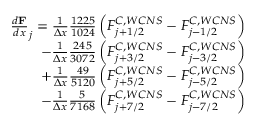<formula> <loc_0><loc_0><loc_500><loc_500>\begin{array} { r } { \frac { d \mathbf F } { d x } _ { j } = \frac { 1 } { \Delta x } \frac { 1 2 2 5 } { 1 0 2 4 } \left ( F _ { j + 1 / 2 } ^ { C , W C N S } - F _ { j - 1 / 2 } ^ { C , W C N S } \right ) } \\ { - \frac { 1 } { \Delta x } \frac { 2 4 5 } { 3 0 7 2 } \left ( F _ { j + 3 / 2 } ^ { C , W C N S } - F _ { j - 3 / 2 } ^ { C , W C N S } \right ) } \\ { + \frac { 1 } { \Delta x } \frac { 4 9 } { 5 1 2 0 } \left ( F _ { j + 5 / 2 } ^ { C , W C N S } - F _ { j - 5 / 2 } ^ { C , W C N S } \right ) } \\ { - \frac { 1 } { \Delta x } \frac { 5 } { 7 1 6 8 } \left ( F _ { j + 7 / 2 } ^ { C , W C N S } - F _ { j - 7 / 2 } ^ { C , W C N S } \right ) } \end{array}</formula> 